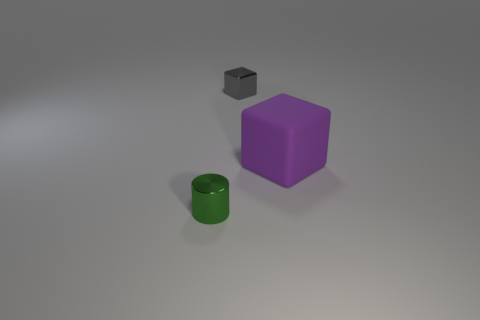Can you describe the shapes and colors of the objects? Certainly! There are three objects: a purple cube with a smooth texture, a green cylinder that appears to possess a shiny surface, and a smaller gray cube with what seems to be a rougher texture. It's an interesting combination of geometric shapes and contrasting colors.  Could these objects be used as teaching aids for a geometry lesson? Definitely. The distinct shapes and colors of these objects make them ideal for a geometry lesson focusing on identifying and differentiating between various forms, such as cubes and cylinders, as well as for discussing properties like edges, faces, and vertices. 